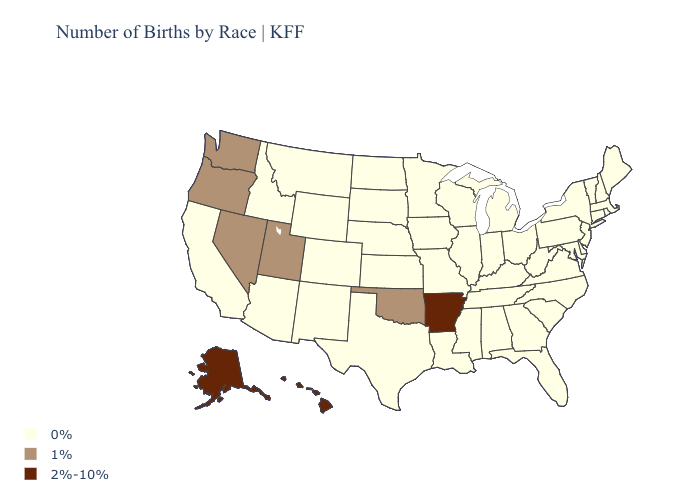What is the highest value in states that border Wisconsin?
Write a very short answer. 0%. Name the states that have a value in the range 1%?
Quick response, please. Nevada, Oklahoma, Oregon, Utah, Washington. Does Wyoming have the lowest value in the West?
Concise answer only. Yes. What is the value of Texas?
Give a very brief answer. 0%. Among the states that border Arizona , which have the highest value?
Answer briefly. Nevada, Utah. What is the value of Illinois?
Quick response, please. 0%. Does Hawaii have the highest value in the USA?
Answer briefly. Yes. Name the states that have a value in the range 1%?
Be succinct. Nevada, Oklahoma, Oregon, Utah, Washington. What is the value of Alaska?
Concise answer only. 2%-10%. Does the first symbol in the legend represent the smallest category?
Give a very brief answer. Yes. Does the first symbol in the legend represent the smallest category?
Quick response, please. Yes. Which states have the lowest value in the USA?
Keep it brief. Alabama, Arizona, California, Colorado, Connecticut, Delaware, Florida, Georgia, Idaho, Illinois, Indiana, Iowa, Kansas, Kentucky, Louisiana, Maine, Maryland, Massachusetts, Michigan, Minnesota, Mississippi, Missouri, Montana, Nebraska, New Hampshire, New Jersey, New Mexico, New York, North Carolina, North Dakota, Ohio, Pennsylvania, Rhode Island, South Carolina, South Dakota, Tennessee, Texas, Vermont, Virginia, West Virginia, Wisconsin, Wyoming. Is the legend a continuous bar?
Answer briefly. No. What is the highest value in states that border Massachusetts?
Be succinct. 0%. What is the value of Maryland?
Answer briefly. 0%. 